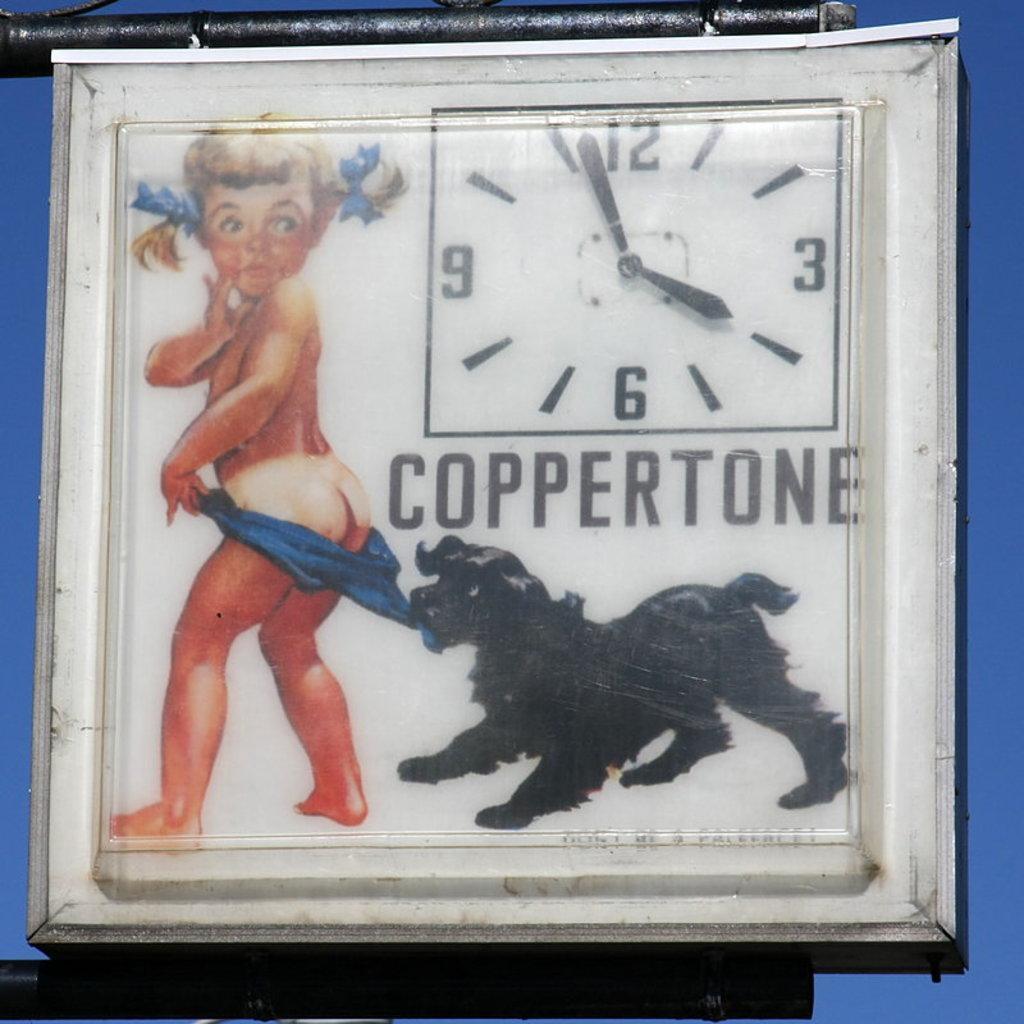What is the primary object in the image? There is a white color clock in the image. What characters are depicted on the clock? The clock has cartoon pictures of a girl and a black color dog. Is there any text present on the clock? Yes, there is text written on the clock. How many eyes does the power have in the image? There is no mention of power or eyes in the image; it features a white color clock with cartoon pictures of a girl and a black color dog, and text. 